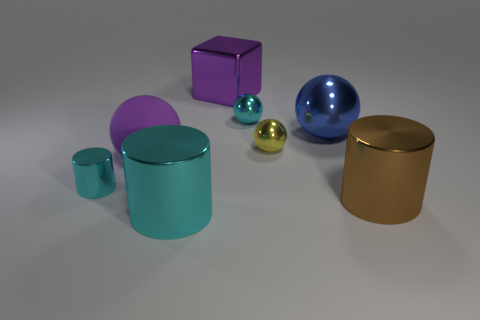Subtract all large blue metallic balls. How many balls are left? 3 Subtract all purple spheres. How many spheres are left? 3 Add 2 large red shiny cylinders. How many objects exist? 10 Subtract all cylinders. How many objects are left? 5 Subtract 1 cylinders. How many cylinders are left? 2 Subtract all brown spheres. How many cyan cylinders are left? 2 Add 8 tiny brown metallic objects. How many tiny brown metallic objects exist? 8 Subtract 0 green cylinders. How many objects are left? 8 Subtract all purple cylinders. Subtract all cyan balls. How many cylinders are left? 3 Subtract all tiny red cylinders. Subtract all large cyan cylinders. How many objects are left? 7 